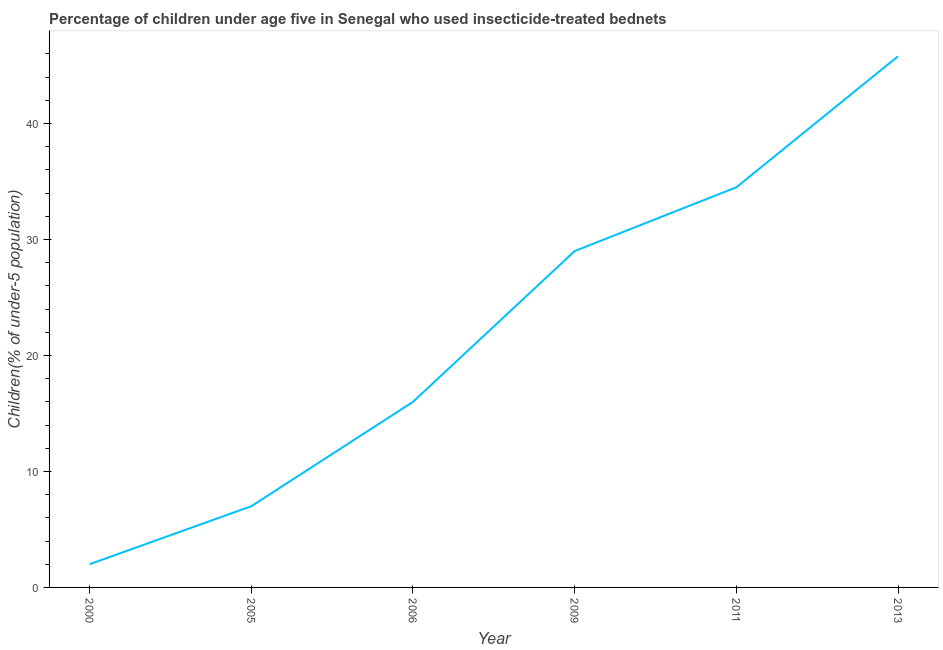Across all years, what is the maximum percentage of children who use of insecticide-treated bed nets?
Keep it short and to the point. 45.8. What is the sum of the percentage of children who use of insecticide-treated bed nets?
Your response must be concise. 134.3. What is the difference between the percentage of children who use of insecticide-treated bed nets in 2005 and 2013?
Give a very brief answer. -38.8. What is the average percentage of children who use of insecticide-treated bed nets per year?
Keep it short and to the point. 22.38. What is the median percentage of children who use of insecticide-treated bed nets?
Give a very brief answer. 22.5. In how many years, is the percentage of children who use of insecticide-treated bed nets greater than 8 %?
Give a very brief answer. 4. Do a majority of the years between 2009 and 2011 (inclusive) have percentage of children who use of insecticide-treated bed nets greater than 16 %?
Give a very brief answer. Yes. What is the ratio of the percentage of children who use of insecticide-treated bed nets in 2005 to that in 2011?
Your answer should be compact. 0.2. Is the percentage of children who use of insecticide-treated bed nets in 2006 less than that in 2009?
Ensure brevity in your answer.  Yes. Is the difference between the percentage of children who use of insecticide-treated bed nets in 2000 and 2011 greater than the difference between any two years?
Your answer should be very brief. No. What is the difference between the highest and the second highest percentage of children who use of insecticide-treated bed nets?
Ensure brevity in your answer.  11.3. What is the difference between the highest and the lowest percentage of children who use of insecticide-treated bed nets?
Keep it short and to the point. 43.8. Does the graph contain any zero values?
Give a very brief answer. No. Does the graph contain grids?
Offer a terse response. No. What is the title of the graph?
Your response must be concise. Percentage of children under age five in Senegal who used insecticide-treated bednets. What is the label or title of the Y-axis?
Your response must be concise. Children(% of under-5 population). What is the Children(% of under-5 population) in 2000?
Provide a succinct answer. 2. What is the Children(% of under-5 population) of 2009?
Provide a short and direct response. 29. What is the Children(% of under-5 population) of 2011?
Give a very brief answer. 34.5. What is the Children(% of under-5 population) of 2013?
Your response must be concise. 45.8. What is the difference between the Children(% of under-5 population) in 2000 and 2009?
Offer a very short reply. -27. What is the difference between the Children(% of under-5 population) in 2000 and 2011?
Offer a terse response. -32.5. What is the difference between the Children(% of under-5 population) in 2000 and 2013?
Your answer should be very brief. -43.8. What is the difference between the Children(% of under-5 population) in 2005 and 2006?
Keep it short and to the point. -9. What is the difference between the Children(% of under-5 population) in 2005 and 2011?
Offer a terse response. -27.5. What is the difference between the Children(% of under-5 population) in 2005 and 2013?
Give a very brief answer. -38.8. What is the difference between the Children(% of under-5 population) in 2006 and 2011?
Provide a succinct answer. -18.5. What is the difference between the Children(% of under-5 population) in 2006 and 2013?
Provide a short and direct response. -29.8. What is the difference between the Children(% of under-5 population) in 2009 and 2011?
Your response must be concise. -5.5. What is the difference between the Children(% of under-5 population) in 2009 and 2013?
Your answer should be compact. -16.8. What is the ratio of the Children(% of under-5 population) in 2000 to that in 2005?
Provide a succinct answer. 0.29. What is the ratio of the Children(% of under-5 population) in 2000 to that in 2006?
Offer a very short reply. 0.12. What is the ratio of the Children(% of under-5 population) in 2000 to that in 2009?
Your answer should be very brief. 0.07. What is the ratio of the Children(% of under-5 population) in 2000 to that in 2011?
Your response must be concise. 0.06. What is the ratio of the Children(% of under-5 population) in 2000 to that in 2013?
Your answer should be very brief. 0.04. What is the ratio of the Children(% of under-5 population) in 2005 to that in 2006?
Make the answer very short. 0.44. What is the ratio of the Children(% of under-5 population) in 2005 to that in 2009?
Ensure brevity in your answer.  0.24. What is the ratio of the Children(% of under-5 population) in 2005 to that in 2011?
Give a very brief answer. 0.2. What is the ratio of the Children(% of under-5 population) in 2005 to that in 2013?
Ensure brevity in your answer.  0.15. What is the ratio of the Children(% of under-5 population) in 2006 to that in 2009?
Ensure brevity in your answer.  0.55. What is the ratio of the Children(% of under-5 population) in 2006 to that in 2011?
Your answer should be very brief. 0.46. What is the ratio of the Children(% of under-5 population) in 2006 to that in 2013?
Your response must be concise. 0.35. What is the ratio of the Children(% of under-5 population) in 2009 to that in 2011?
Your response must be concise. 0.84. What is the ratio of the Children(% of under-5 population) in 2009 to that in 2013?
Offer a very short reply. 0.63. What is the ratio of the Children(% of under-5 population) in 2011 to that in 2013?
Your response must be concise. 0.75. 